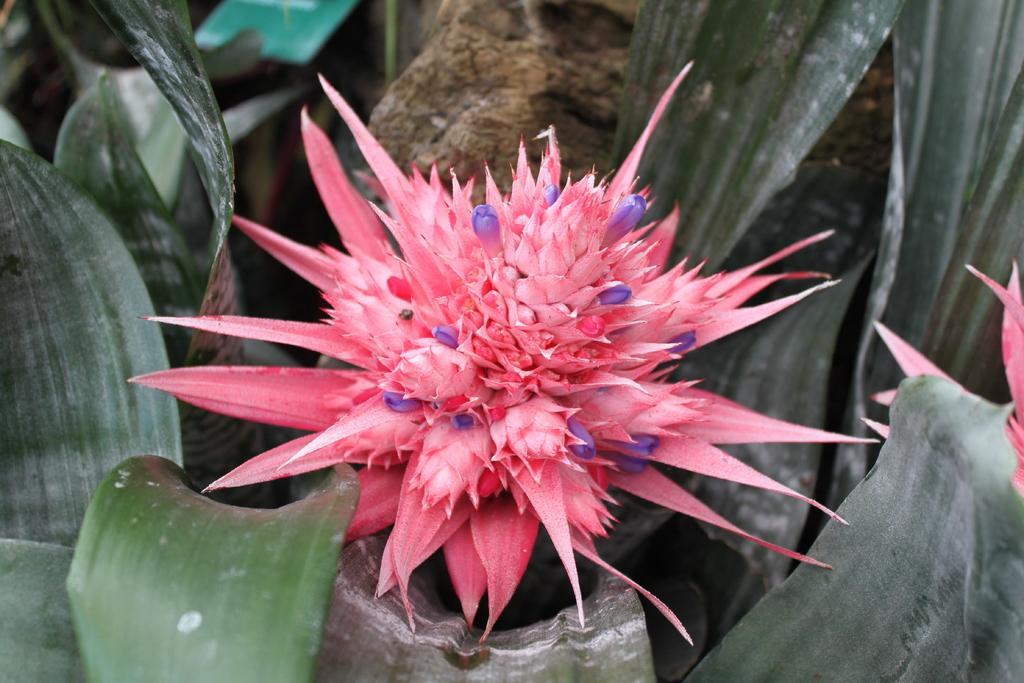How would you summarize this image in a sentence or two? In the center of the image we can see a flower and there are leaves. 